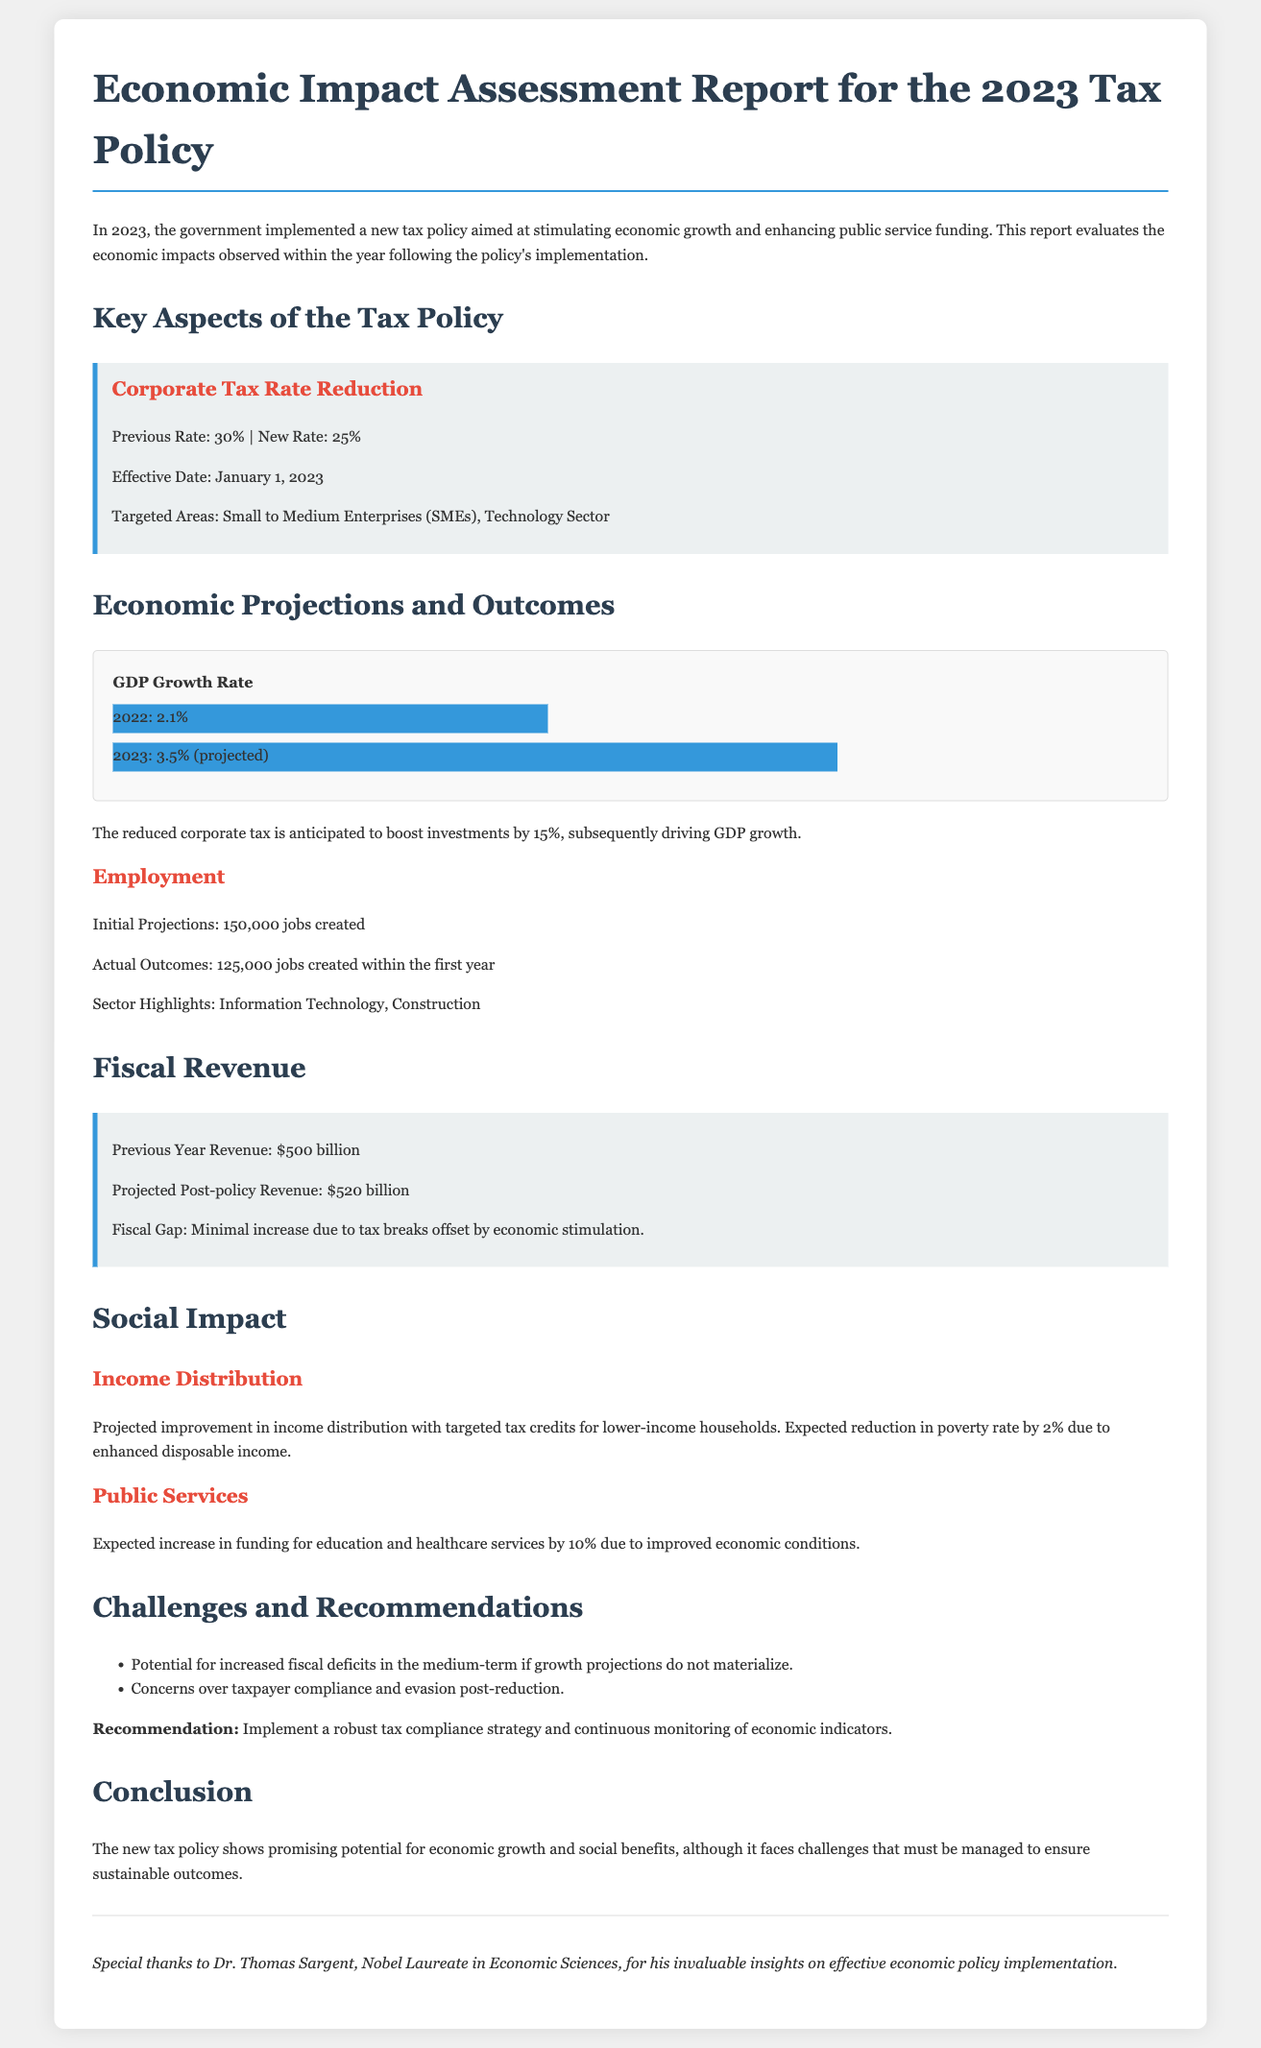What is the new corporate tax rate? The document specifies the new corporate tax rate after the reduction, which is 25%.
Answer: 25% What is the projected GDP growth rate for 2023? The report presents the projected GDP growth rate for 2023 as 3.5%.
Answer: 3.5% How many jobs were initially projected to be created? According to the document, the initial projections indicated that 150,000 jobs would be created.
Answer: 150,000 What was the revenue from the previous year? The previous year's revenue is mentioned in the report as $500 billion.
Answer: $500 billion What is the expected increase in funding for public services? The document notes an expected increase in funding for public services by 10%.
Answer: 10% What challenge is mentioned regarding taxpayer behavior? The report highlights concerns over taxpayer compliance and evasion as a challenge.
Answer: Tax compliance What is the anticipated fiscal revenue after the policy implementation? The projected post-policy revenue is stated to be $520 billion in the report.
Answer: $520 billion Who contributed to the insights on effective economic policy implementation? The document acknowledges Dr. Thomas Sargent for his invaluable insights.
Answer: Dr. Thomas Sargent What is the expected reduction in the poverty rate? The report anticipates a reduction in the poverty rate by 2% due to enhanced disposable income.
Answer: 2% 